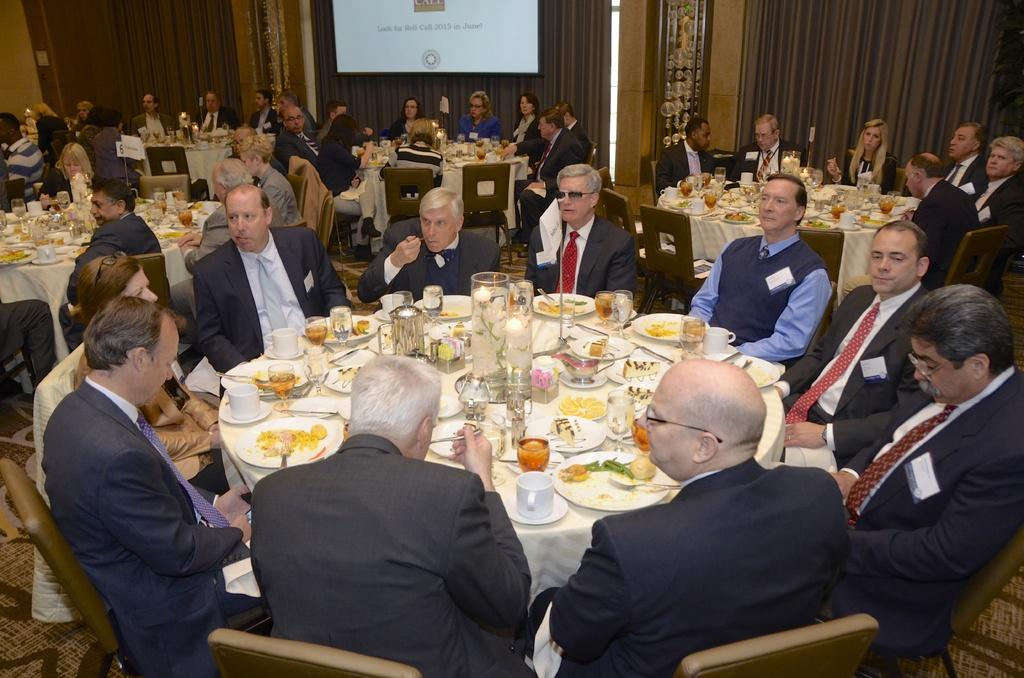What is located behind the curtain in the image? There is a screen behind the curtain. What are the people in the image doing? The persons in the image are sitting on chairs. What objects are in front of the chairs? There are tables in front of the chairs. What items can be found on the tables? There is a plate, cups, glasses, and candles on the table. What type of food is present on the table? There is food on the table. Can you tell me who is giving a haircut to the person in the image? There is no haircut being given in the image; the persons are sitting on chairs with tables in front of them. What type of spade is being used to serve the food on the table? There is no spade present in the image; the food is served on a plate. 